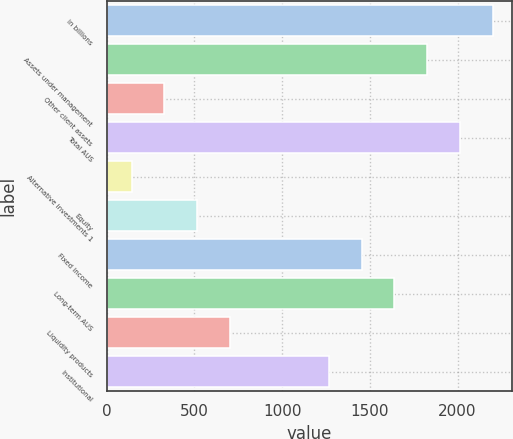<chart> <loc_0><loc_0><loc_500><loc_500><bar_chart><fcel>in billions<fcel>Assets under management<fcel>Other client assets<fcel>Total AUS<fcel>Alternative investments 1<fcel>Equity<fcel>Fixed income<fcel>Long-term AUS<fcel>Liquidity products<fcel>Institutional<nl><fcel>2201.1<fcel>1826.9<fcel>330.1<fcel>2014<fcel>143<fcel>517.2<fcel>1452.7<fcel>1639.8<fcel>704.3<fcel>1265.6<nl></chart> 